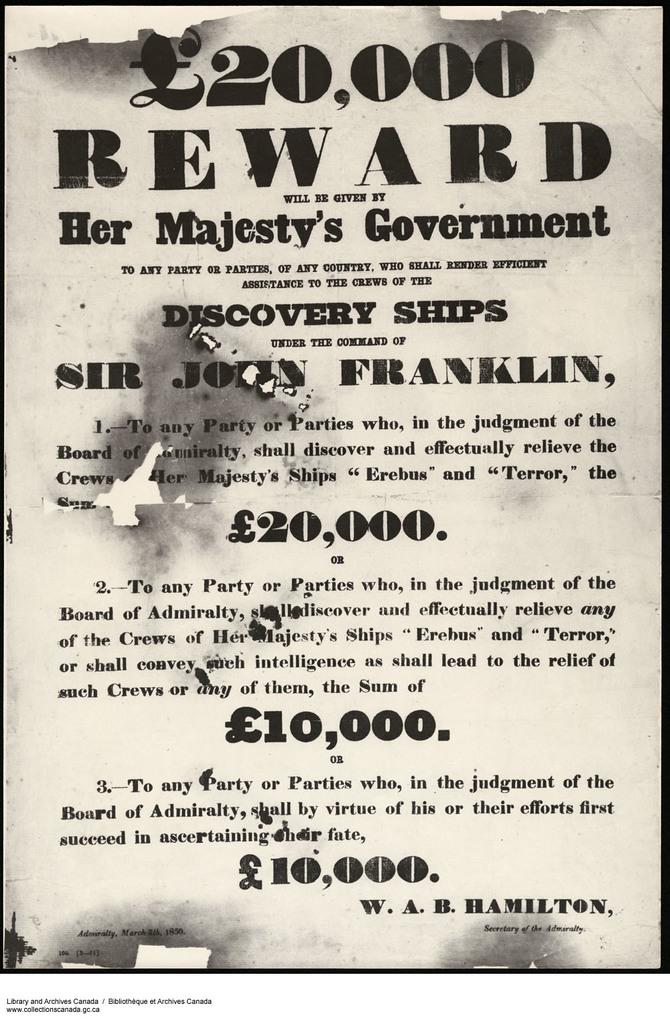<image>
Describe the image concisely. An old flyer from W.A.B. Hamilton offers a reward from her majesty's government. 